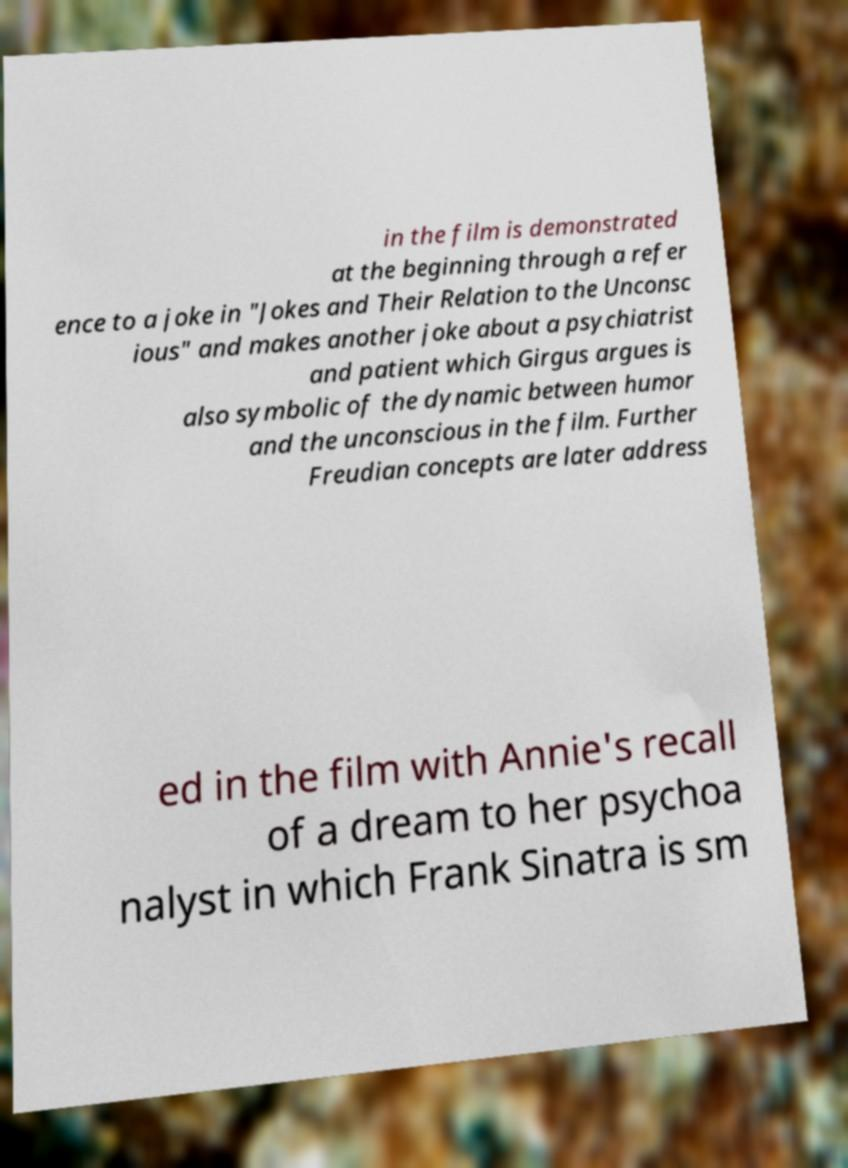Please read and relay the text visible in this image. What does it say? in the film is demonstrated at the beginning through a refer ence to a joke in "Jokes and Their Relation to the Unconsc ious" and makes another joke about a psychiatrist and patient which Girgus argues is also symbolic of the dynamic between humor and the unconscious in the film. Further Freudian concepts are later address ed in the film with Annie's recall of a dream to her psychoa nalyst in which Frank Sinatra is sm 